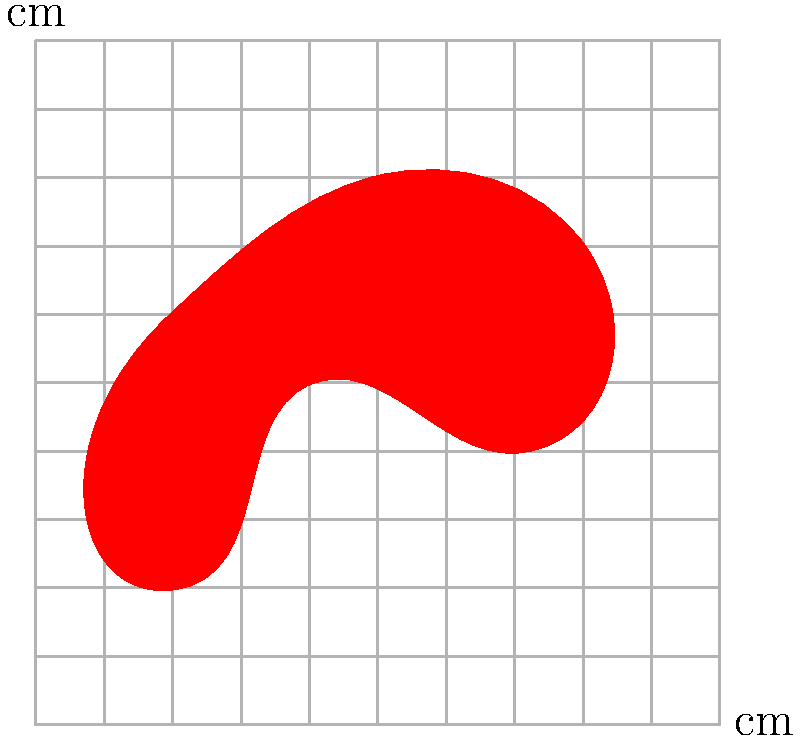Un perro llega a la clínica con una herida irregular en su piel. Usando el papel cuadriculado proporcionado, donde cada cuadrado representa 0.5 cm x 0.5 cm, estime el área de la herida en cm². Redondee su respuesta al cm² más cercano.

[In English: A dog arrives at the clinic with an irregular wound on its skin. Using the provided grid paper, where each square represents 0.5 cm x 0.5 cm, estimate the area of the wound in cm². Round your answer to the nearest cm².] Para estimar el área de la herida irregular, seguiremos estos pasos:

1) Contamos los cuadrados completos dentro de la herida. Hay aproximadamente 18 cuadrados completos.

2) Estimamos los cuadrados parciales como mitades. Hay alrededor de 22 cuadrados parciales que podemos contar como 11 cuadrados completos.

3) Sumamos los cuadrados completos y los estimados:
   $18 + 11 = 29$ cuadrados

4) Cada cuadrado representa $0.5 \text{ cm} \times 0.5 \text{ cm} = 0.25 \text{ cm}^2$

5) Calculamos el área total:
   $29 \times 0.25 \text{ cm}^2 = 7.25 \text{ cm}^2$

6) Redondeamos al cm² más cercano:
   $7.25 \text{ cm}^2 \approx 7 \text{ cm}^2$

Por lo tanto, el área estimada de la herida es aproximadamente 7 cm².
Answer: 7 cm² 